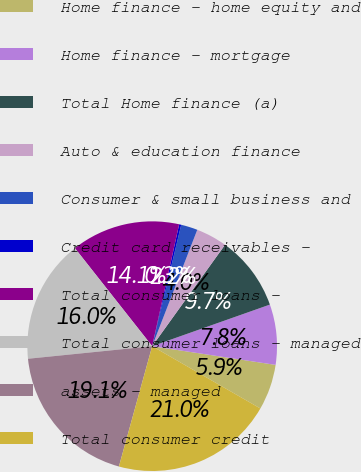Convert chart to OTSL. <chart><loc_0><loc_0><loc_500><loc_500><pie_chart><fcel>Home finance - home equity and<fcel>Home finance - mortgage<fcel>Total Home finance (a)<fcel>Auto & education finance<fcel>Consumer & small business and<fcel>Credit card receivables -<fcel>Total consumer loans -<fcel>Total consumer loans - managed<fcel>assets - managed<fcel>Total consumer credit<nl><fcel>5.92%<fcel>7.8%<fcel>9.68%<fcel>4.03%<fcel>2.15%<fcel>0.27%<fcel>14.09%<fcel>15.98%<fcel>19.1%<fcel>20.98%<nl></chart> 